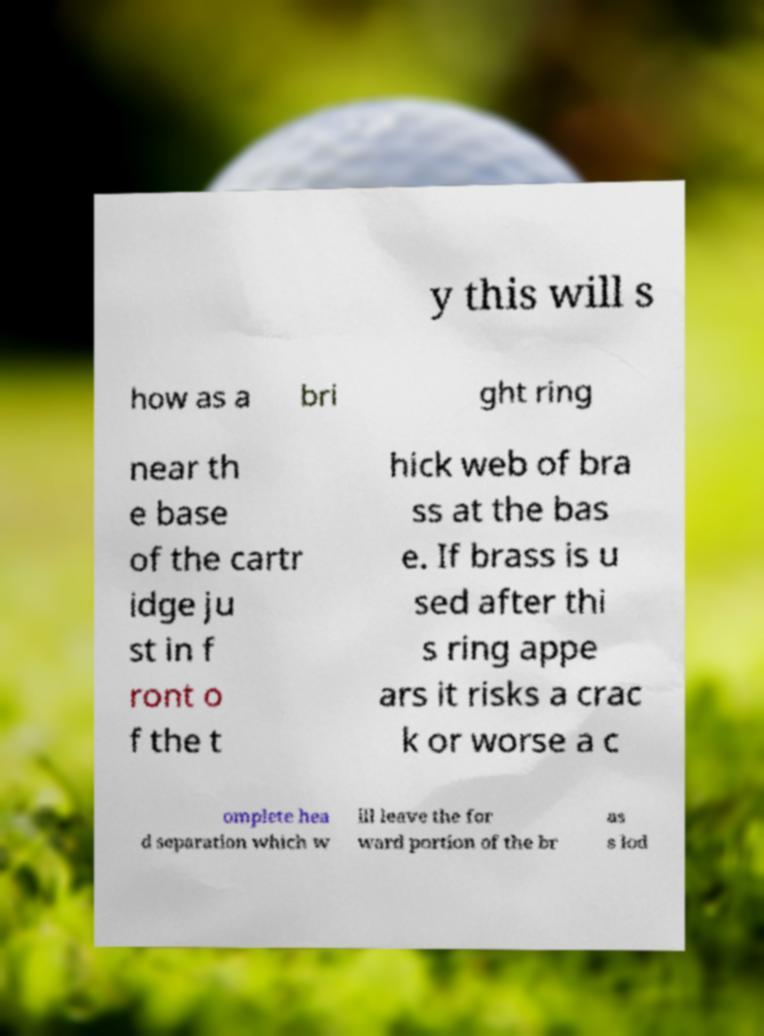Could you assist in decoding the text presented in this image and type it out clearly? y this will s how as a bri ght ring near th e base of the cartr idge ju st in f ront o f the t hick web of bra ss at the bas e. If brass is u sed after thi s ring appe ars it risks a crac k or worse a c omplete hea d separation which w ill leave the for ward portion of the br as s lod 